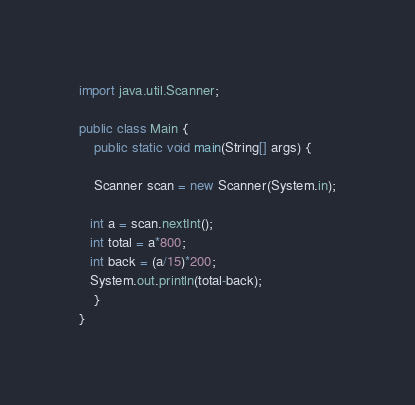Convert code to text. <code><loc_0><loc_0><loc_500><loc_500><_Java_>import java.util.Scanner;

public class Main {
    public static void main(String[] args) {

    Scanner scan = new Scanner(System.in);
    
   int a = scan.nextInt();
   int total = a*800;
   int back = (a/15)*200;
   System.out.println(total-back);
    }
}
</code> 